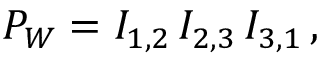Convert formula to latex. <formula><loc_0><loc_0><loc_500><loc_500>P _ { W } = I _ { 1 , 2 } \, I _ { 2 , 3 } \, I _ { 3 , 1 } \, ,</formula> 